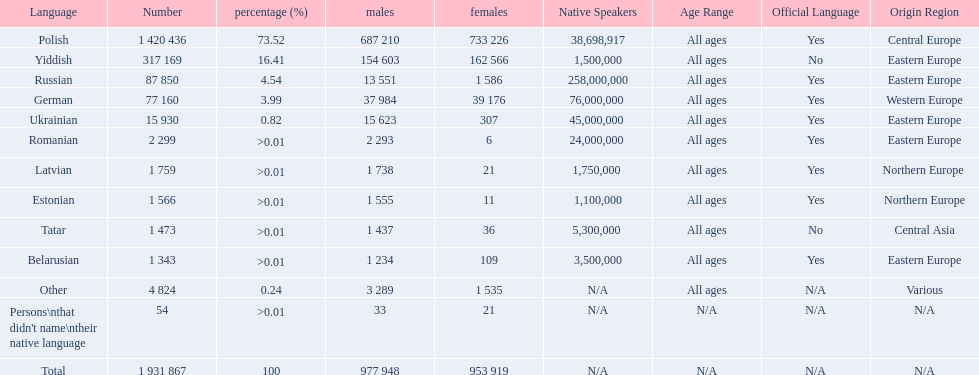What is the highest percentage of speakers other than polish? Yiddish. 